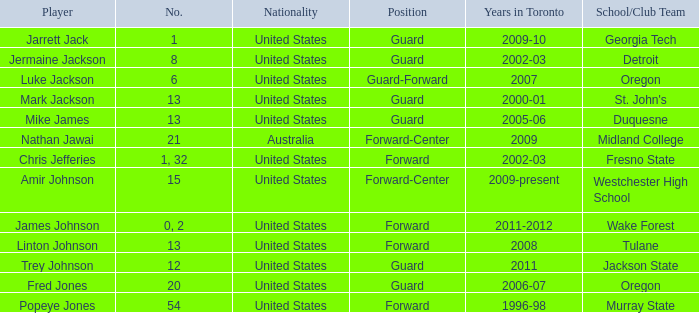Which school/club group is trey johnson a member of? Jackson State. 